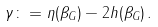<formula> <loc_0><loc_0><loc_500><loc_500>\gamma \colon = \eta ( \beta _ { G } ) - 2 h ( \beta _ { G } ) \, .</formula> 